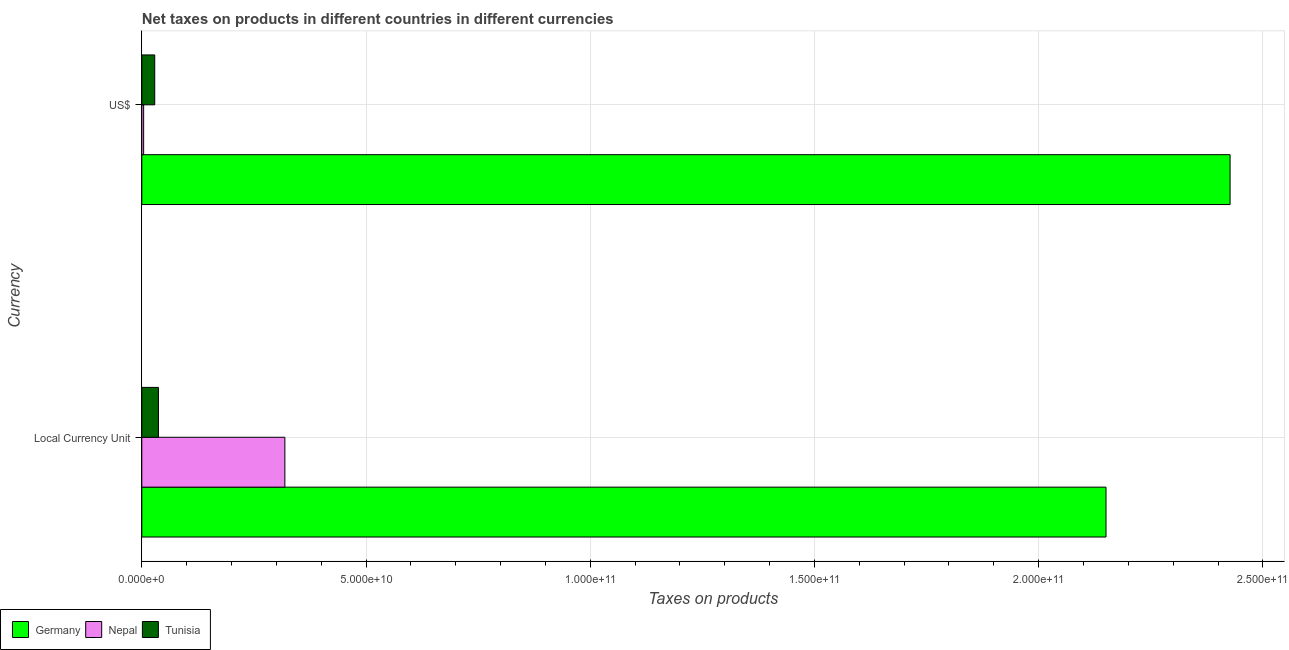What is the label of the 1st group of bars from the top?
Offer a terse response. US$. What is the net taxes in constant 2005 us$ in Nepal?
Give a very brief answer. 3.19e+1. Across all countries, what is the maximum net taxes in us$?
Make the answer very short. 2.43e+11. Across all countries, what is the minimum net taxes in us$?
Make the answer very short. 4.10e+08. In which country was the net taxes in us$ maximum?
Your response must be concise. Germany. In which country was the net taxes in constant 2005 us$ minimum?
Make the answer very short. Tunisia. What is the total net taxes in constant 2005 us$ in the graph?
Your answer should be compact. 2.51e+11. What is the difference between the net taxes in us$ in Nepal and that in Germany?
Offer a terse response. -2.42e+11. What is the difference between the net taxes in us$ in Germany and the net taxes in constant 2005 us$ in Nepal?
Keep it short and to the point. 2.11e+11. What is the average net taxes in us$ per country?
Give a very brief answer. 8.20e+1. What is the difference between the net taxes in us$ and net taxes in constant 2005 us$ in Germany?
Provide a succinct answer. 2.77e+1. What is the ratio of the net taxes in us$ in Tunisia to that in Nepal?
Offer a very short reply. 7.02. What does the 2nd bar from the top in Local Currency Unit represents?
Keep it short and to the point. Nepal. What does the 1st bar from the bottom in US$ represents?
Keep it short and to the point. Germany. How many bars are there?
Your response must be concise. 6. Does the graph contain any zero values?
Offer a terse response. No. What is the title of the graph?
Offer a very short reply. Net taxes on products in different countries in different currencies. What is the label or title of the X-axis?
Make the answer very short. Taxes on products. What is the label or title of the Y-axis?
Offer a terse response. Currency. What is the Taxes on products in Germany in Local Currency Unit?
Your response must be concise. 2.15e+11. What is the Taxes on products in Nepal in Local Currency Unit?
Give a very brief answer. 3.19e+1. What is the Taxes on products of Tunisia in Local Currency Unit?
Give a very brief answer. 3.71e+09. What is the Taxes on products of Germany in US$?
Offer a terse response. 2.43e+11. What is the Taxes on products of Nepal in US$?
Provide a short and direct response. 4.10e+08. What is the Taxes on products in Tunisia in US$?
Provide a succinct answer. 2.88e+09. Across all Currency, what is the maximum Taxes on products in Germany?
Make the answer very short. 2.43e+11. Across all Currency, what is the maximum Taxes on products of Nepal?
Provide a short and direct response. 3.19e+1. Across all Currency, what is the maximum Taxes on products in Tunisia?
Your answer should be compact. 3.71e+09. Across all Currency, what is the minimum Taxes on products of Germany?
Offer a terse response. 2.15e+11. Across all Currency, what is the minimum Taxes on products in Nepal?
Provide a succinct answer. 4.10e+08. Across all Currency, what is the minimum Taxes on products of Tunisia?
Your answer should be compact. 2.88e+09. What is the total Taxes on products in Germany in the graph?
Your answer should be compact. 4.58e+11. What is the total Taxes on products in Nepal in the graph?
Your response must be concise. 3.23e+1. What is the total Taxes on products of Tunisia in the graph?
Offer a terse response. 6.59e+09. What is the difference between the Taxes on products of Germany in Local Currency Unit and that in US$?
Provide a succinct answer. -2.77e+1. What is the difference between the Taxes on products in Nepal in Local Currency Unit and that in US$?
Offer a very short reply. 3.15e+1. What is the difference between the Taxes on products in Tunisia in Local Currency Unit and that in US$?
Offer a terse response. 8.31e+08. What is the difference between the Taxes on products in Germany in Local Currency Unit and the Taxes on products in Nepal in US$?
Offer a very short reply. 2.15e+11. What is the difference between the Taxes on products in Germany in Local Currency Unit and the Taxes on products in Tunisia in US$?
Your answer should be very brief. 2.12e+11. What is the difference between the Taxes on products of Nepal in Local Currency Unit and the Taxes on products of Tunisia in US$?
Offer a terse response. 2.90e+1. What is the average Taxes on products of Germany per Currency?
Make the answer very short. 2.29e+11. What is the average Taxes on products in Nepal per Currency?
Give a very brief answer. 1.62e+1. What is the average Taxes on products in Tunisia per Currency?
Give a very brief answer. 3.30e+09. What is the difference between the Taxes on products in Germany and Taxes on products in Nepal in Local Currency Unit?
Your answer should be very brief. 1.83e+11. What is the difference between the Taxes on products of Germany and Taxes on products of Tunisia in Local Currency Unit?
Ensure brevity in your answer.  2.11e+11. What is the difference between the Taxes on products of Nepal and Taxes on products of Tunisia in Local Currency Unit?
Provide a short and direct response. 2.82e+1. What is the difference between the Taxes on products in Germany and Taxes on products in Nepal in US$?
Your answer should be compact. 2.42e+11. What is the difference between the Taxes on products of Germany and Taxes on products of Tunisia in US$?
Offer a very short reply. 2.40e+11. What is the difference between the Taxes on products in Nepal and Taxes on products in Tunisia in US$?
Ensure brevity in your answer.  -2.47e+09. What is the ratio of the Taxes on products in Germany in Local Currency Unit to that in US$?
Offer a very short reply. 0.89. What is the ratio of the Taxes on products in Nepal in Local Currency Unit to that in US$?
Offer a terse response. 77.76. What is the ratio of the Taxes on products of Tunisia in Local Currency Unit to that in US$?
Make the answer very short. 1.29. What is the difference between the highest and the second highest Taxes on products in Germany?
Offer a very short reply. 2.77e+1. What is the difference between the highest and the second highest Taxes on products of Nepal?
Your answer should be very brief. 3.15e+1. What is the difference between the highest and the second highest Taxes on products in Tunisia?
Ensure brevity in your answer.  8.31e+08. What is the difference between the highest and the lowest Taxes on products in Germany?
Provide a short and direct response. 2.77e+1. What is the difference between the highest and the lowest Taxes on products in Nepal?
Ensure brevity in your answer.  3.15e+1. What is the difference between the highest and the lowest Taxes on products in Tunisia?
Offer a terse response. 8.31e+08. 